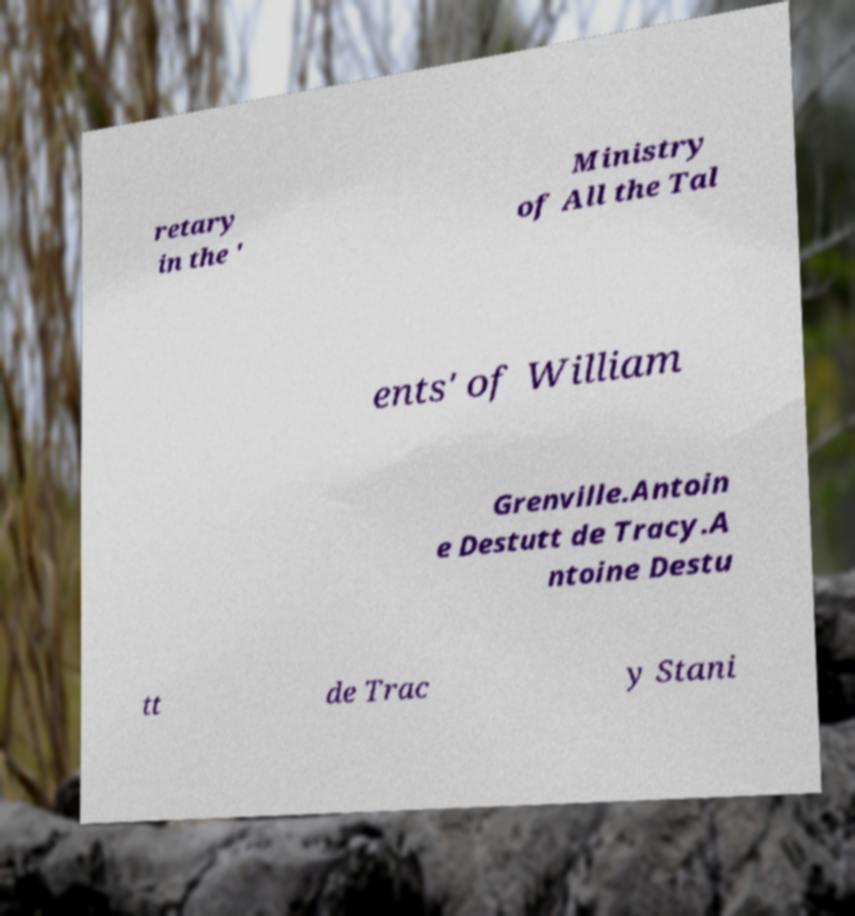For documentation purposes, I need the text within this image transcribed. Could you provide that? retary in the ' Ministry of All the Tal ents' of William Grenville.Antoin e Destutt de Tracy.A ntoine Destu tt de Trac y Stani 